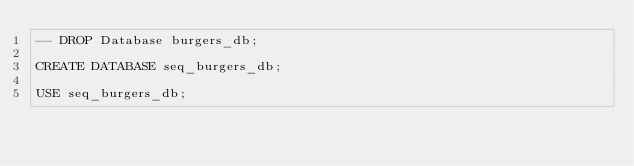<code> <loc_0><loc_0><loc_500><loc_500><_SQL_>-- DROP Database burgers_db;

CREATE DATABASE seq_burgers_db;

USE seq_burgers_db;

</code> 